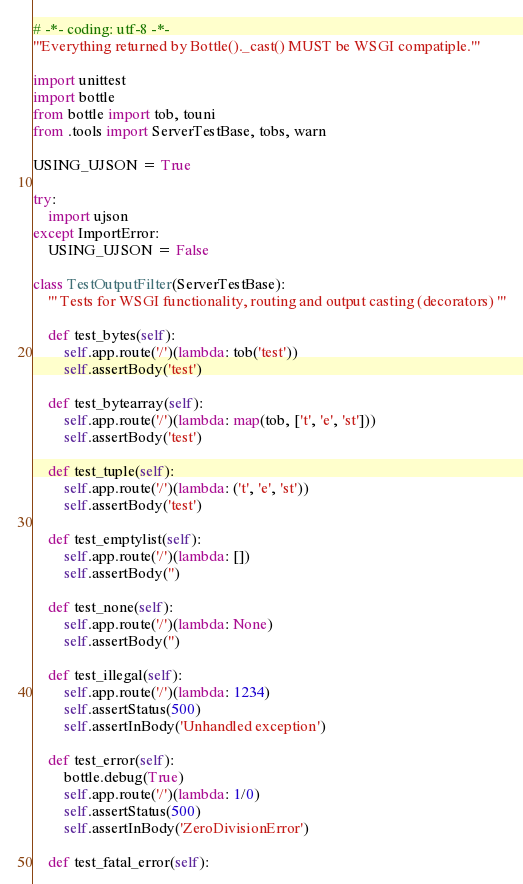Convert code to text. <code><loc_0><loc_0><loc_500><loc_500><_Python_># -*- coding: utf-8 -*-
'''Everything returned by Bottle()._cast() MUST be WSGI compatiple.'''

import unittest
import bottle
from bottle import tob, touni
from .tools import ServerTestBase, tobs, warn

USING_UJSON = True

try:
    import ujson
except ImportError:
    USING_UJSON = False

class TestOutputFilter(ServerTestBase):
    ''' Tests for WSGI functionality, routing and output casting (decorators) '''

    def test_bytes(self):
        self.app.route('/')(lambda: tob('test'))
        self.assertBody('test')

    def test_bytearray(self):
        self.app.route('/')(lambda: map(tob, ['t', 'e', 'st']))
        self.assertBody('test')

    def test_tuple(self):
        self.app.route('/')(lambda: ('t', 'e', 'st'))
        self.assertBody('test')

    def test_emptylist(self):
        self.app.route('/')(lambda: [])
        self.assertBody('')

    def test_none(self):
        self.app.route('/')(lambda: None)
        self.assertBody('')

    def test_illegal(self):
        self.app.route('/')(lambda: 1234)
        self.assertStatus(500)
        self.assertInBody('Unhandled exception')

    def test_error(self):
        bottle.debug(True)
        self.app.route('/')(lambda: 1/0)
        self.assertStatus(500)
        self.assertInBody('ZeroDivisionError')

    def test_fatal_error(self):</code> 